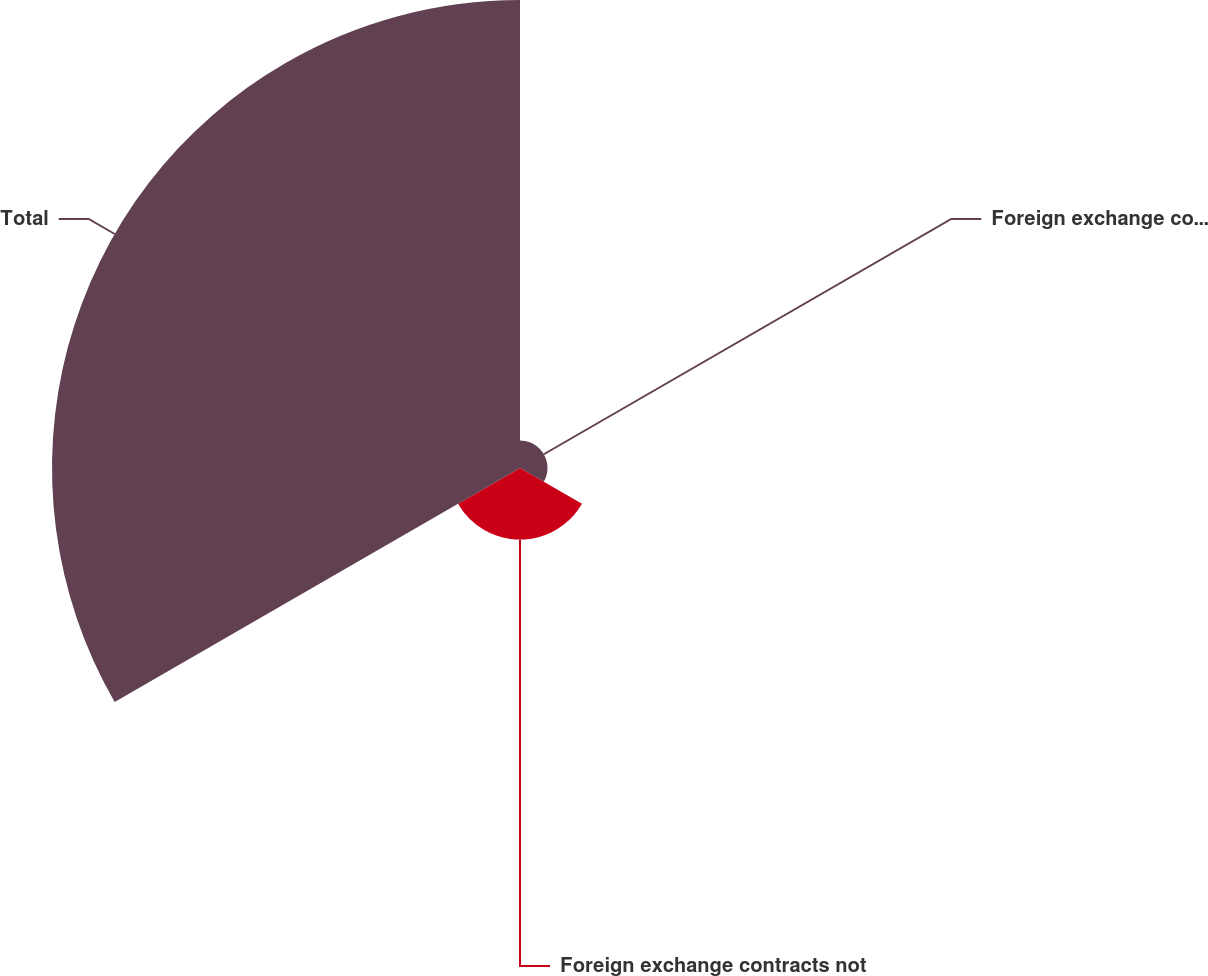Convert chart to OTSL. <chart><loc_0><loc_0><loc_500><loc_500><pie_chart><fcel>Foreign exchange contracts<fcel>Foreign exchange contracts not<fcel>Total<nl><fcel>4.85%<fcel>12.62%<fcel>82.52%<nl></chart> 